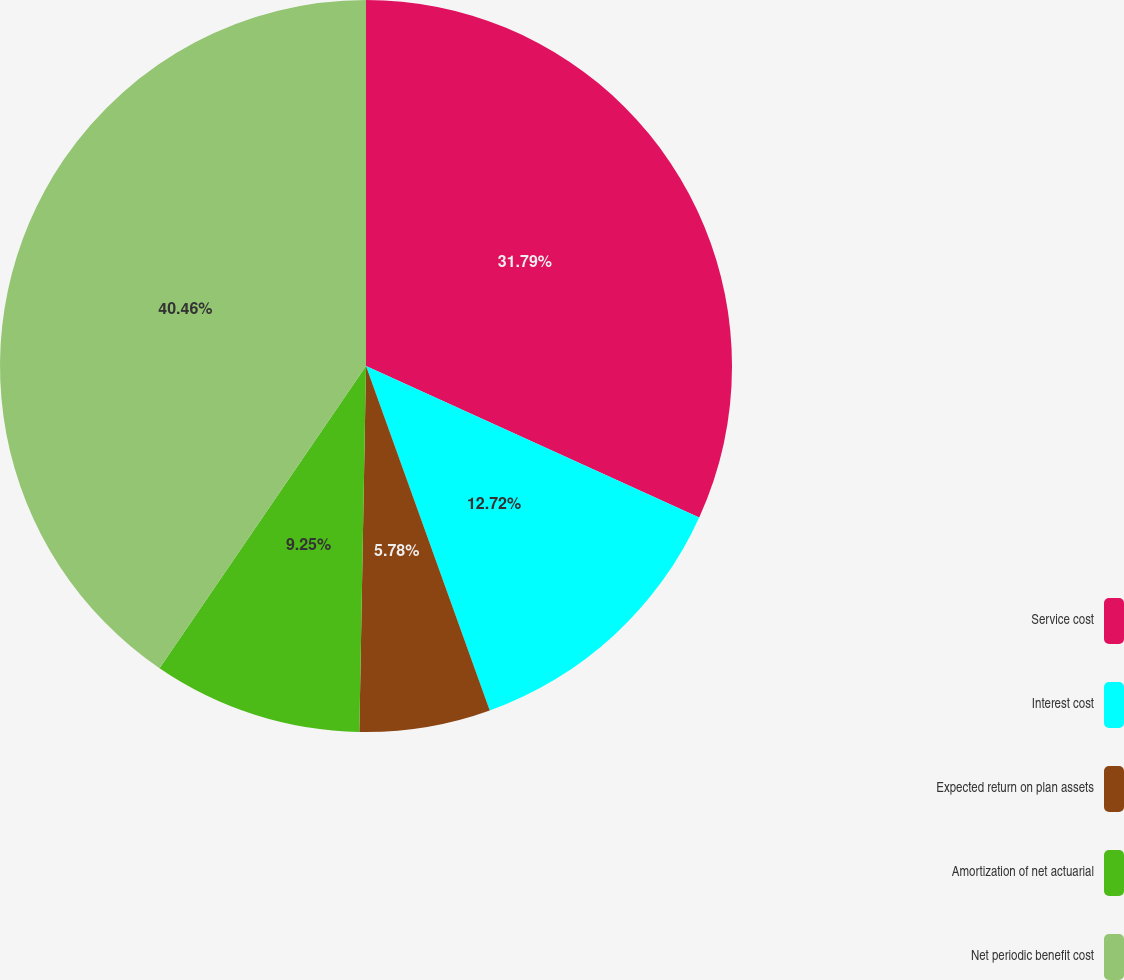<chart> <loc_0><loc_0><loc_500><loc_500><pie_chart><fcel>Service cost<fcel>Interest cost<fcel>Expected return on plan assets<fcel>Amortization of net actuarial<fcel>Net periodic benefit cost<nl><fcel>31.79%<fcel>12.72%<fcel>5.78%<fcel>9.25%<fcel>40.46%<nl></chart> 